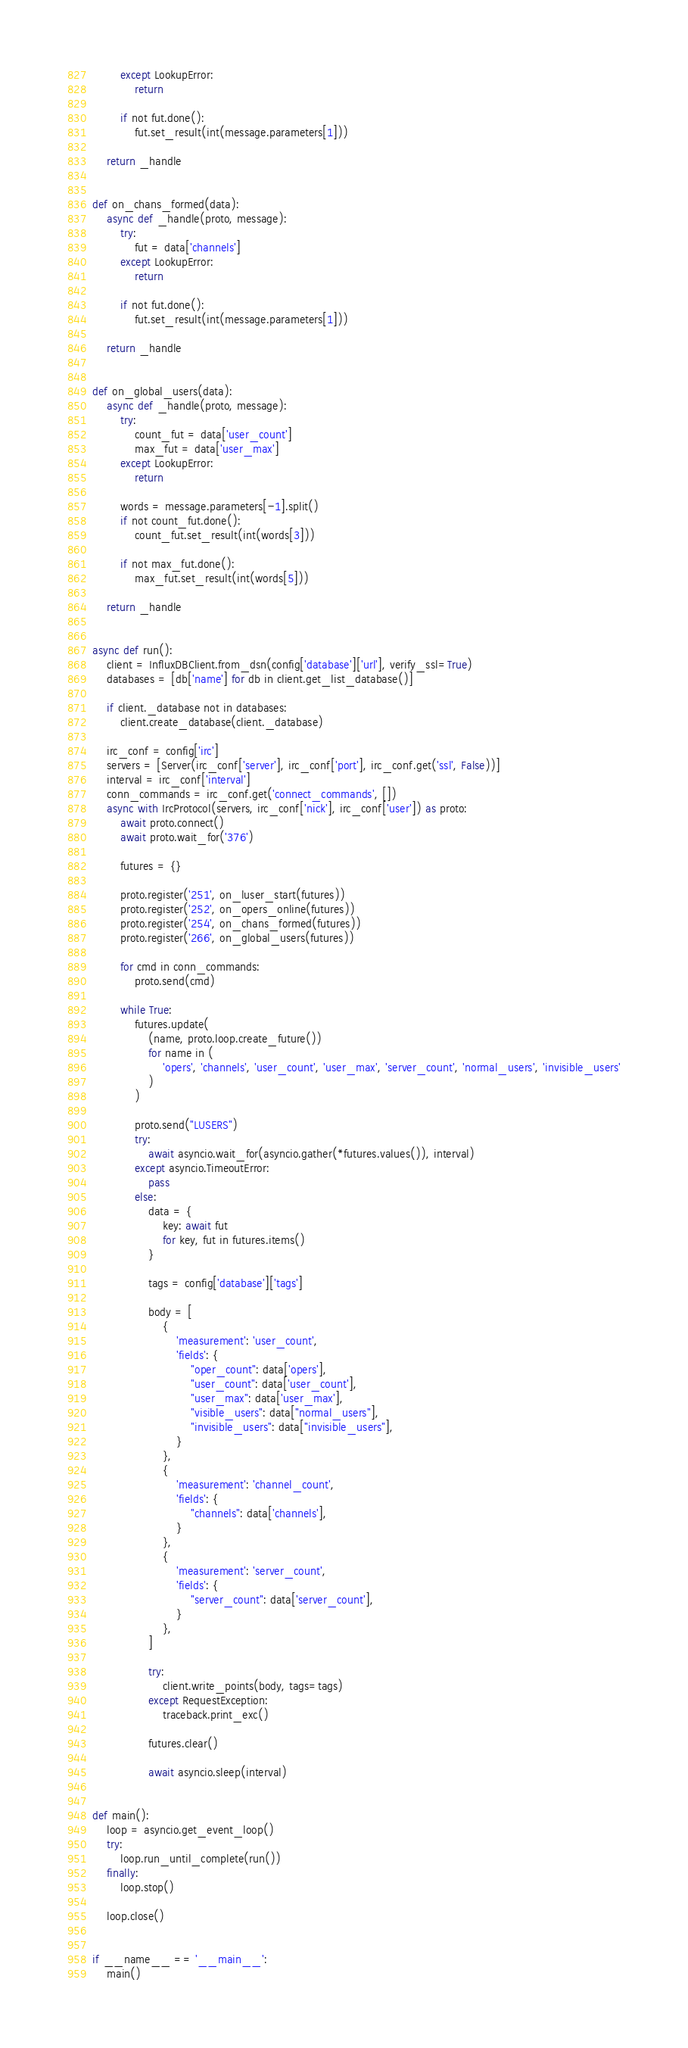Convert code to text. <code><loc_0><loc_0><loc_500><loc_500><_Python_>        except LookupError:
            return

        if not fut.done():
            fut.set_result(int(message.parameters[1]))

    return _handle


def on_chans_formed(data):
    async def _handle(proto, message):
        try:
            fut = data['channels']
        except LookupError:
            return

        if not fut.done():
            fut.set_result(int(message.parameters[1]))

    return _handle


def on_global_users(data):
    async def _handle(proto, message):
        try:
            count_fut = data['user_count']
            max_fut = data['user_max']
        except LookupError:
            return

        words = message.parameters[-1].split()
        if not count_fut.done():
            count_fut.set_result(int(words[3]))

        if not max_fut.done():
            max_fut.set_result(int(words[5]))

    return _handle


async def run():
    client = InfluxDBClient.from_dsn(config['database']['url'], verify_ssl=True)
    databases = [db['name'] for db in client.get_list_database()]

    if client._database not in databases:
        client.create_database(client._database)

    irc_conf = config['irc']
    servers = [Server(irc_conf['server'], irc_conf['port'], irc_conf.get('ssl', False))]
    interval = irc_conf['interval']
    conn_commands = irc_conf.get('connect_commands', [])
    async with IrcProtocol(servers, irc_conf['nick'], irc_conf['user']) as proto:
        await proto.connect()
        await proto.wait_for('376')

        futures = {}

        proto.register('251', on_luser_start(futures))
        proto.register('252', on_opers_online(futures))
        proto.register('254', on_chans_formed(futures))
        proto.register('266', on_global_users(futures))

        for cmd in conn_commands:
            proto.send(cmd)

        while True:
            futures.update(
                (name, proto.loop.create_future())
                for name in (
                    'opers', 'channels', 'user_count', 'user_max', 'server_count', 'normal_users', 'invisible_users'
                )
            )

            proto.send("LUSERS")
            try:
                await asyncio.wait_for(asyncio.gather(*futures.values()), interval)
            except asyncio.TimeoutError:
                pass
            else:
                data = {
                    key: await fut
                    for key, fut in futures.items()
                }

                tags = config['database']['tags']

                body = [
                    {
                        'measurement': 'user_count',
                        'fields': {
                            "oper_count": data['opers'],
                            "user_count": data['user_count'],
                            "user_max": data['user_max'],
                            "visible_users": data["normal_users"],
                            "invisible_users": data["invisible_users"],
                        }
                    },
                    {
                        'measurement': 'channel_count',
                        'fields': {
                            "channels": data['channels'],
                        }
                    },
                    {
                        'measurement': 'server_count',
                        'fields': {
                            "server_count": data['server_count'],
                        }
                    },
                ]

                try:
                    client.write_points(body, tags=tags)
                except RequestException:
                    traceback.print_exc()

                futures.clear()

                await asyncio.sleep(interval)


def main():
    loop = asyncio.get_event_loop()
    try:
        loop.run_until_complete(run())
    finally:
        loop.stop()

    loop.close()


if __name__ == '__main__':
    main()
</code> 